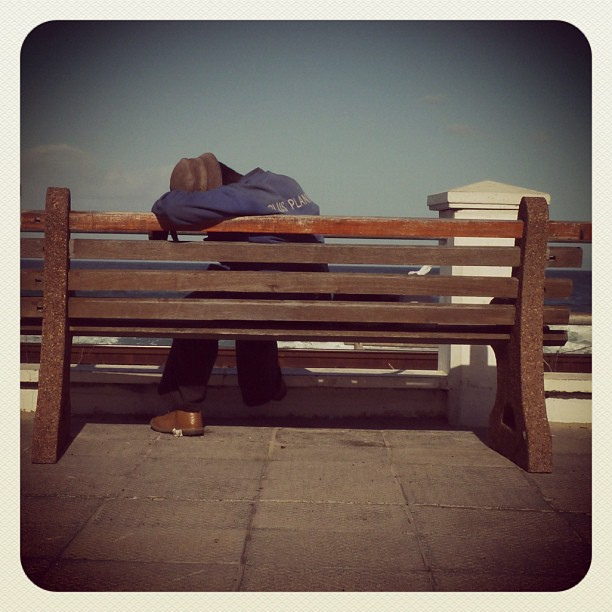Read and extract the text from this image. PLAN 